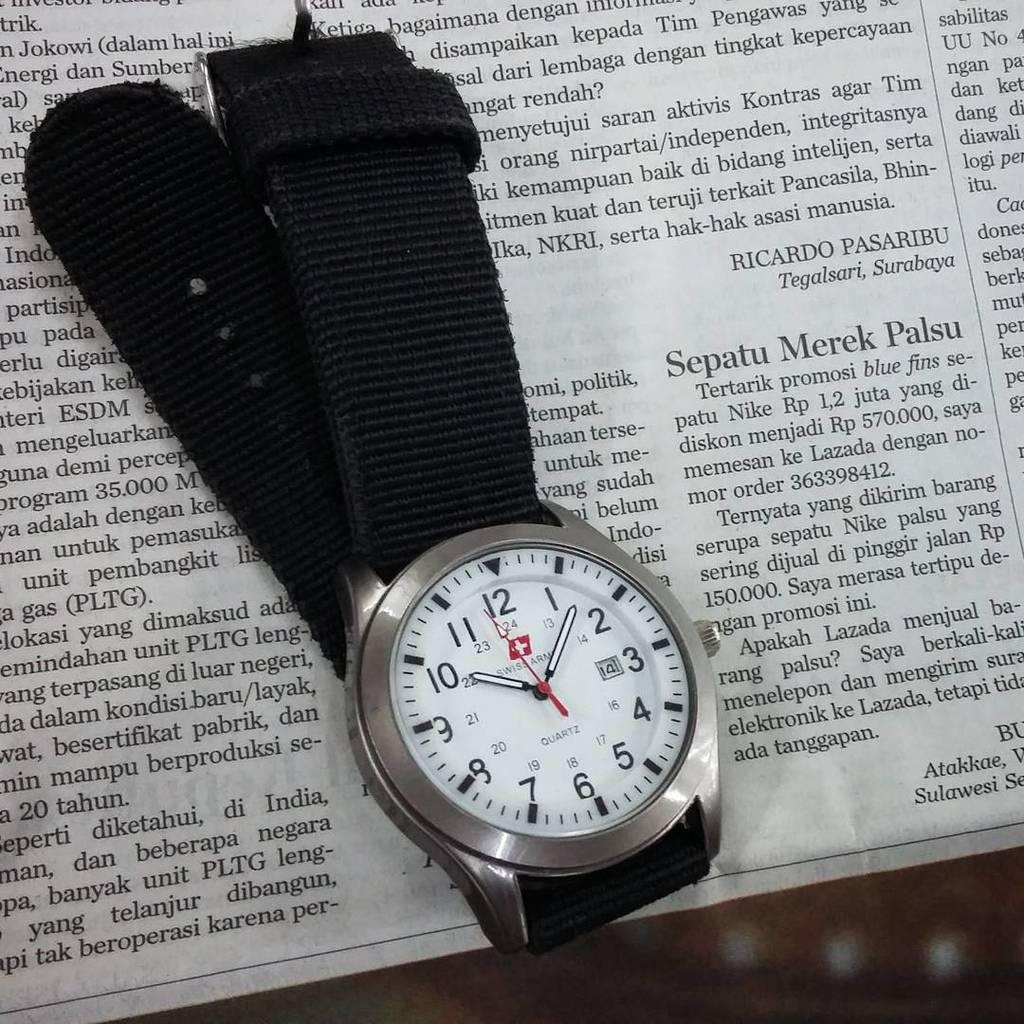<image>
Write a terse but informative summary of the picture. A Swiss Army is placed on top of a newspaper. 